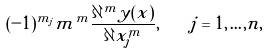<formula> <loc_0><loc_0><loc_500><loc_500>( - 1 ) ^ { m _ { j } } m ^ { m } \frac { \partial ^ { m } y ( x ) } { \partial x _ { j } ^ { m } } , \quad j = 1 , \dots , n ,</formula> 